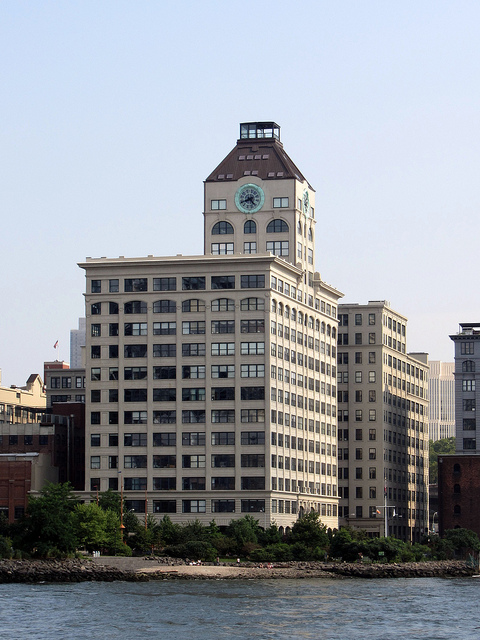<image>What is the building in the background? I don't know what is the exact building in the background. It could be an office building, apartments, a clock tower, a prison, or something else. What is the building in the background? I am not sure what the building in the background is. It can be apartments, office, residential, prison, clock tower, Sears, office building, or something else. 